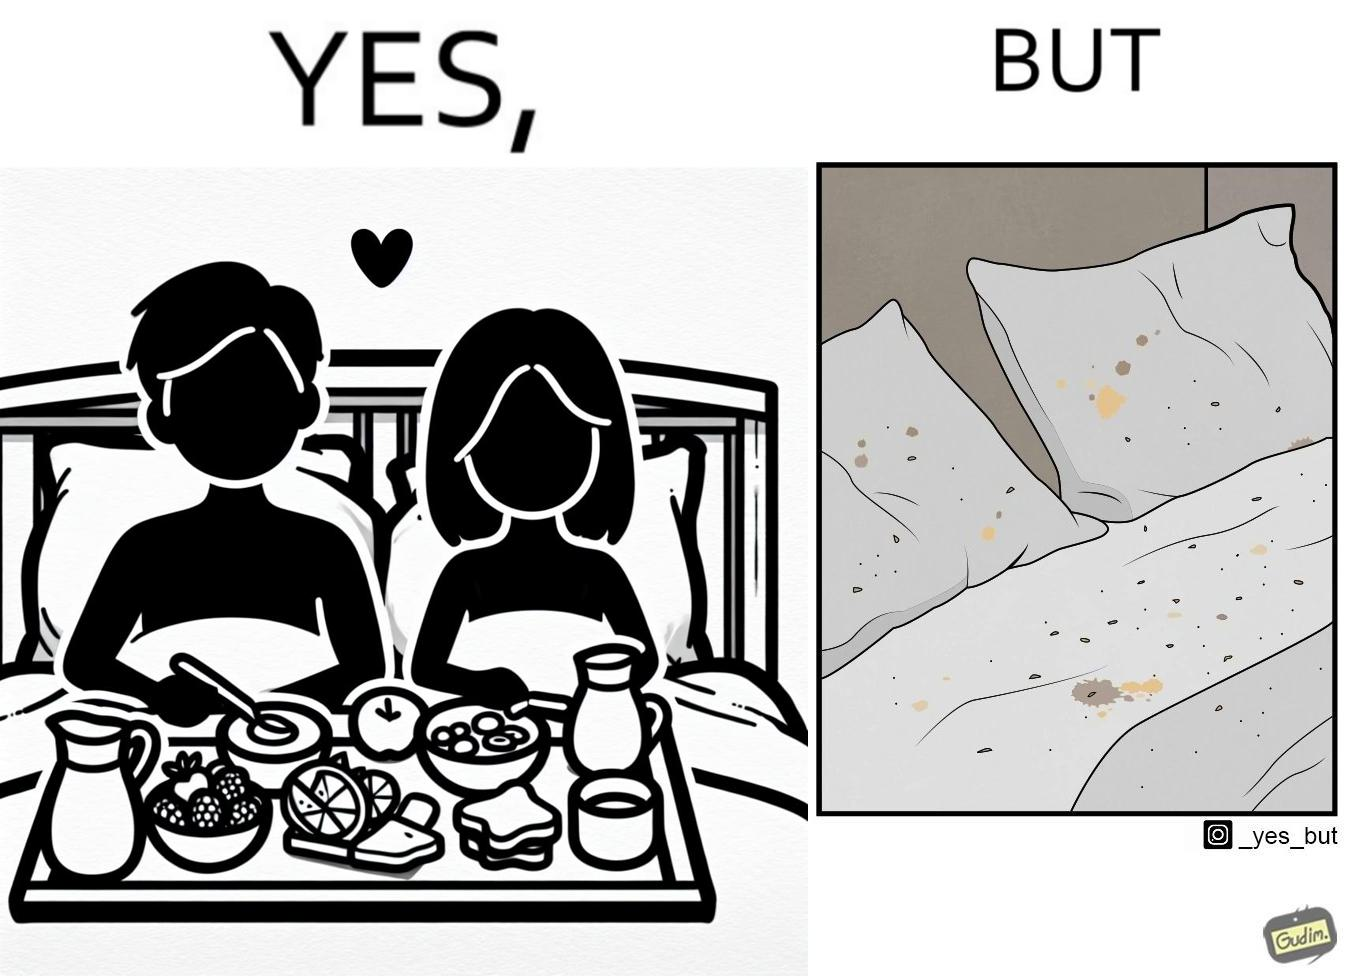Would you classify this image as satirical? Yes, this image is satirical. 